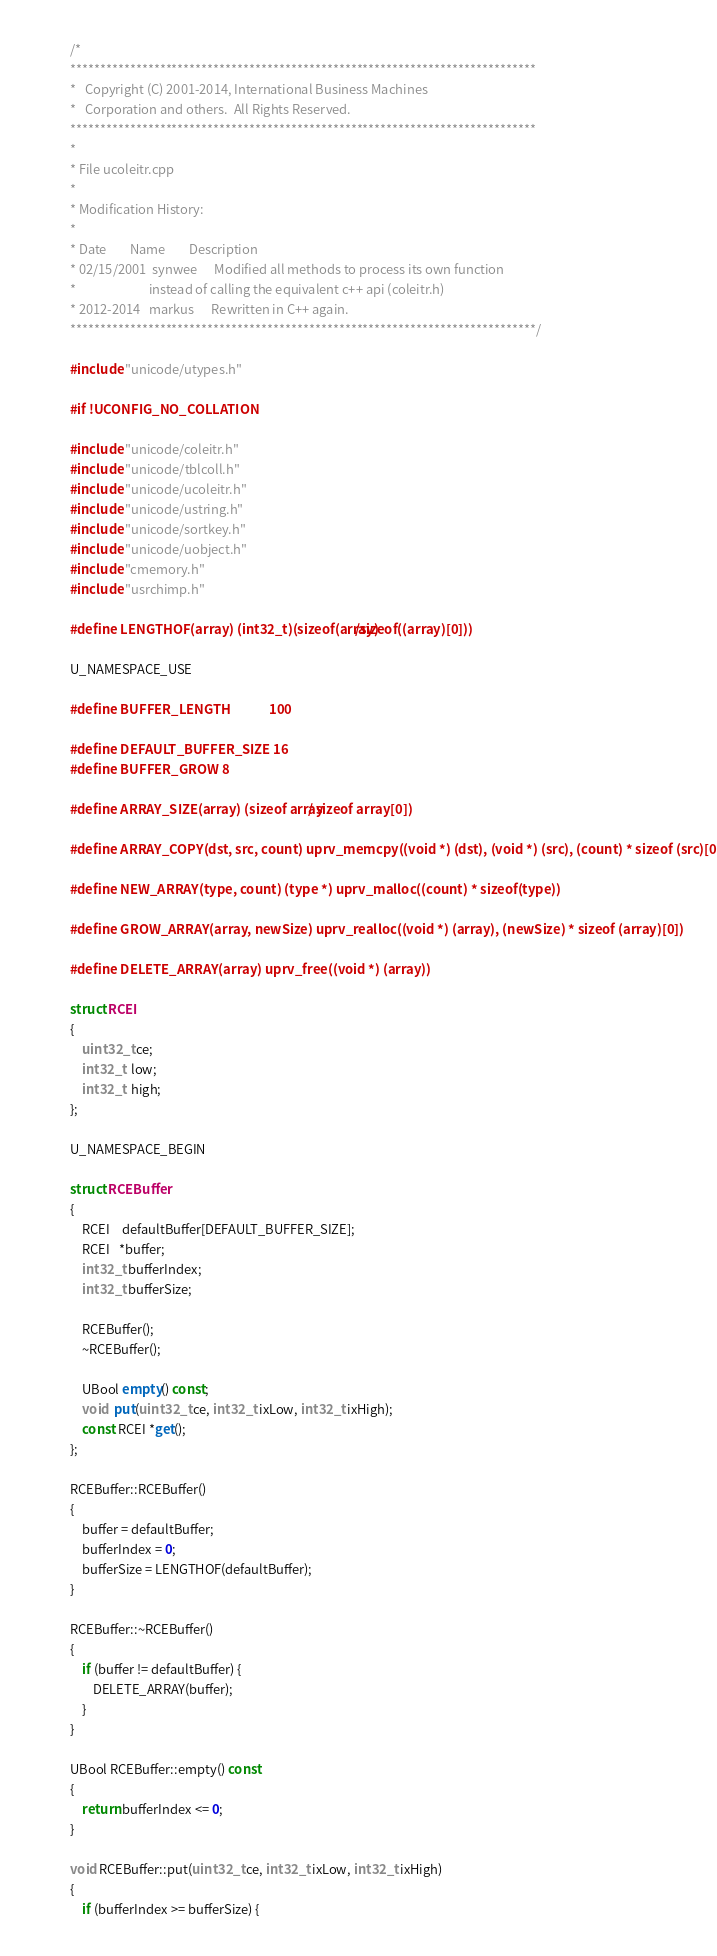<code> <loc_0><loc_0><loc_500><loc_500><_C++_>/*
******************************************************************************
*   Copyright (C) 2001-2014, International Business Machines
*   Corporation and others.  All Rights Reserved.
******************************************************************************
*
* File ucoleitr.cpp
*
* Modification History:
*
* Date        Name        Description
* 02/15/2001  synwee      Modified all methods to process its own function 
*                         instead of calling the equivalent c++ api (coleitr.h)
* 2012-2014   markus      Rewritten in C++ again.
******************************************************************************/

#include "unicode/utypes.h"

#if !UCONFIG_NO_COLLATION

#include "unicode/coleitr.h"
#include "unicode/tblcoll.h"
#include "unicode/ucoleitr.h"
#include "unicode/ustring.h"
#include "unicode/sortkey.h"
#include "unicode/uobject.h"
#include "cmemory.h"
#include "usrchimp.h"

#define LENGTHOF(array) (int32_t)(sizeof(array)/sizeof((array)[0]))

U_NAMESPACE_USE

#define BUFFER_LENGTH             100

#define DEFAULT_BUFFER_SIZE 16
#define BUFFER_GROW 8

#define ARRAY_SIZE(array) (sizeof array / sizeof array[0])

#define ARRAY_COPY(dst, src, count) uprv_memcpy((void *) (dst), (void *) (src), (count) * sizeof (src)[0])

#define NEW_ARRAY(type, count) (type *) uprv_malloc((count) * sizeof(type))

#define GROW_ARRAY(array, newSize) uprv_realloc((void *) (array), (newSize) * sizeof (array)[0])

#define DELETE_ARRAY(array) uprv_free((void *) (array))

struct RCEI
{
    uint32_t ce;
    int32_t  low;
    int32_t  high;
};

U_NAMESPACE_BEGIN

struct RCEBuffer
{
    RCEI    defaultBuffer[DEFAULT_BUFFER_SIZE];
    RCEI   *buffer;
    int32_t bufferIndex;
    int32_t bufferSize;

    RCEBuffer();
    ~RCEBuffer();

    UBool empty() const;
    void  put(uint32_t ce, int32_t ixLow, int32_t ixHigh);
    const RCEI *get();
};

RCEBuffer::RCEBuffer()
{
    buffer = defaultBuffer;
    bufferIndex = 0;
    bufferSize = LENGTHOF(defaultBuffer);
}

RCEBuffer::~RCEBuffer()
{
    if (buffer != defaultBuffer) {
        DELETE_ARRAY(buffer);
    }
}

UBool RCEBuffer::empty() const
{
    return bufferIndex <= 0;
}

void RCEBuffer::put(uint32_t ce, int32_t ixLow, int32_t ixHigh)
{
    if (bufferIndex >= bufferSize) {</code> 